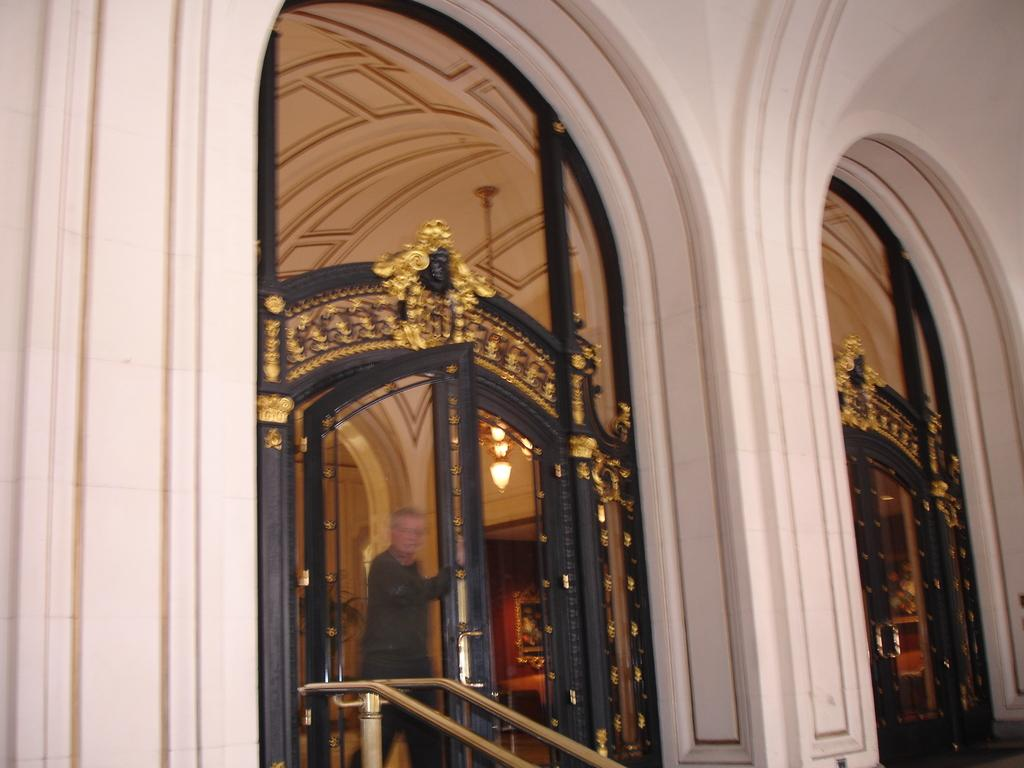What type of structure is depicted in the image? There are walls and a roof in the image, suggesting a building or house. Can you describe any openings in the structure? Yes, there are doors in the image. What is the person in the image doing? The person is opening a door in the image. What type of range can be seen in the image? There is no range present in the image. How many eyes does the person in the image have? The image does not show the person's eyes, so it cannot be determined how many eyes they have. 